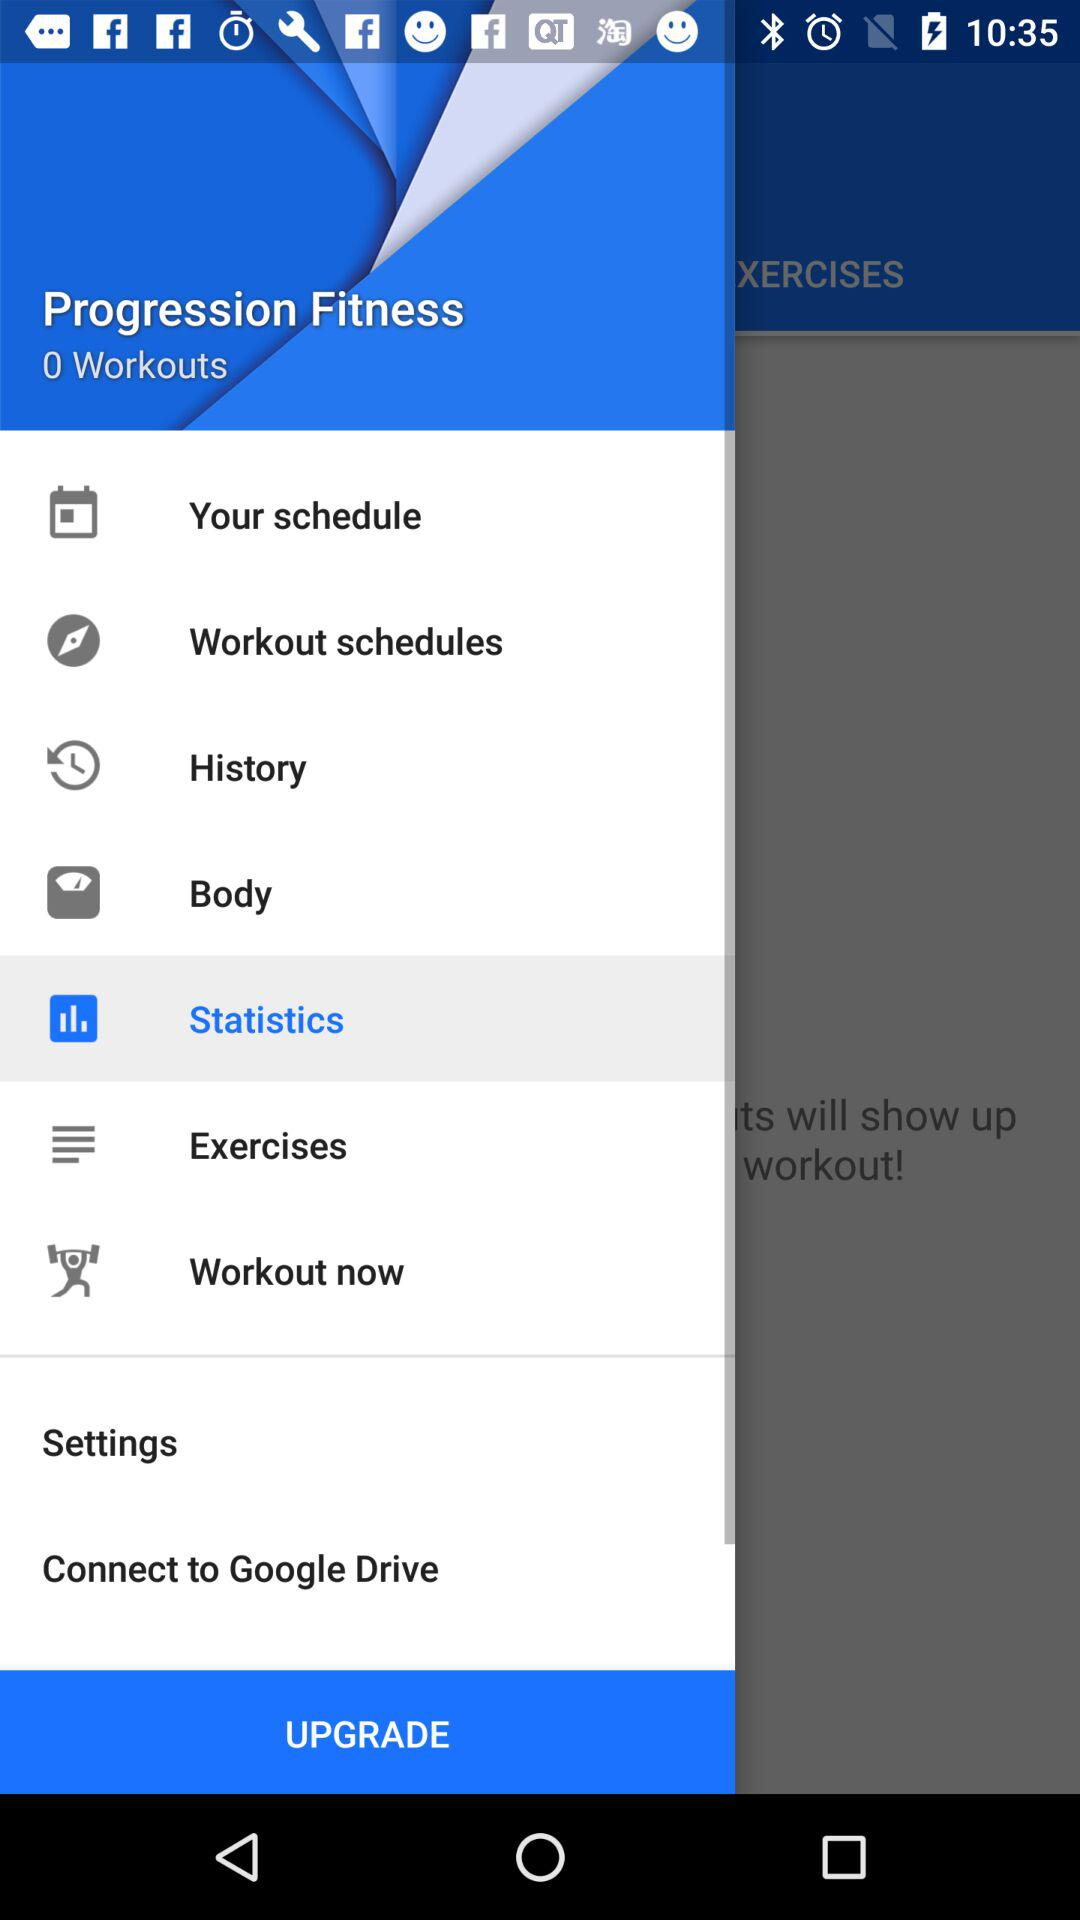Which item is selected? The selected item is "Statistics". 